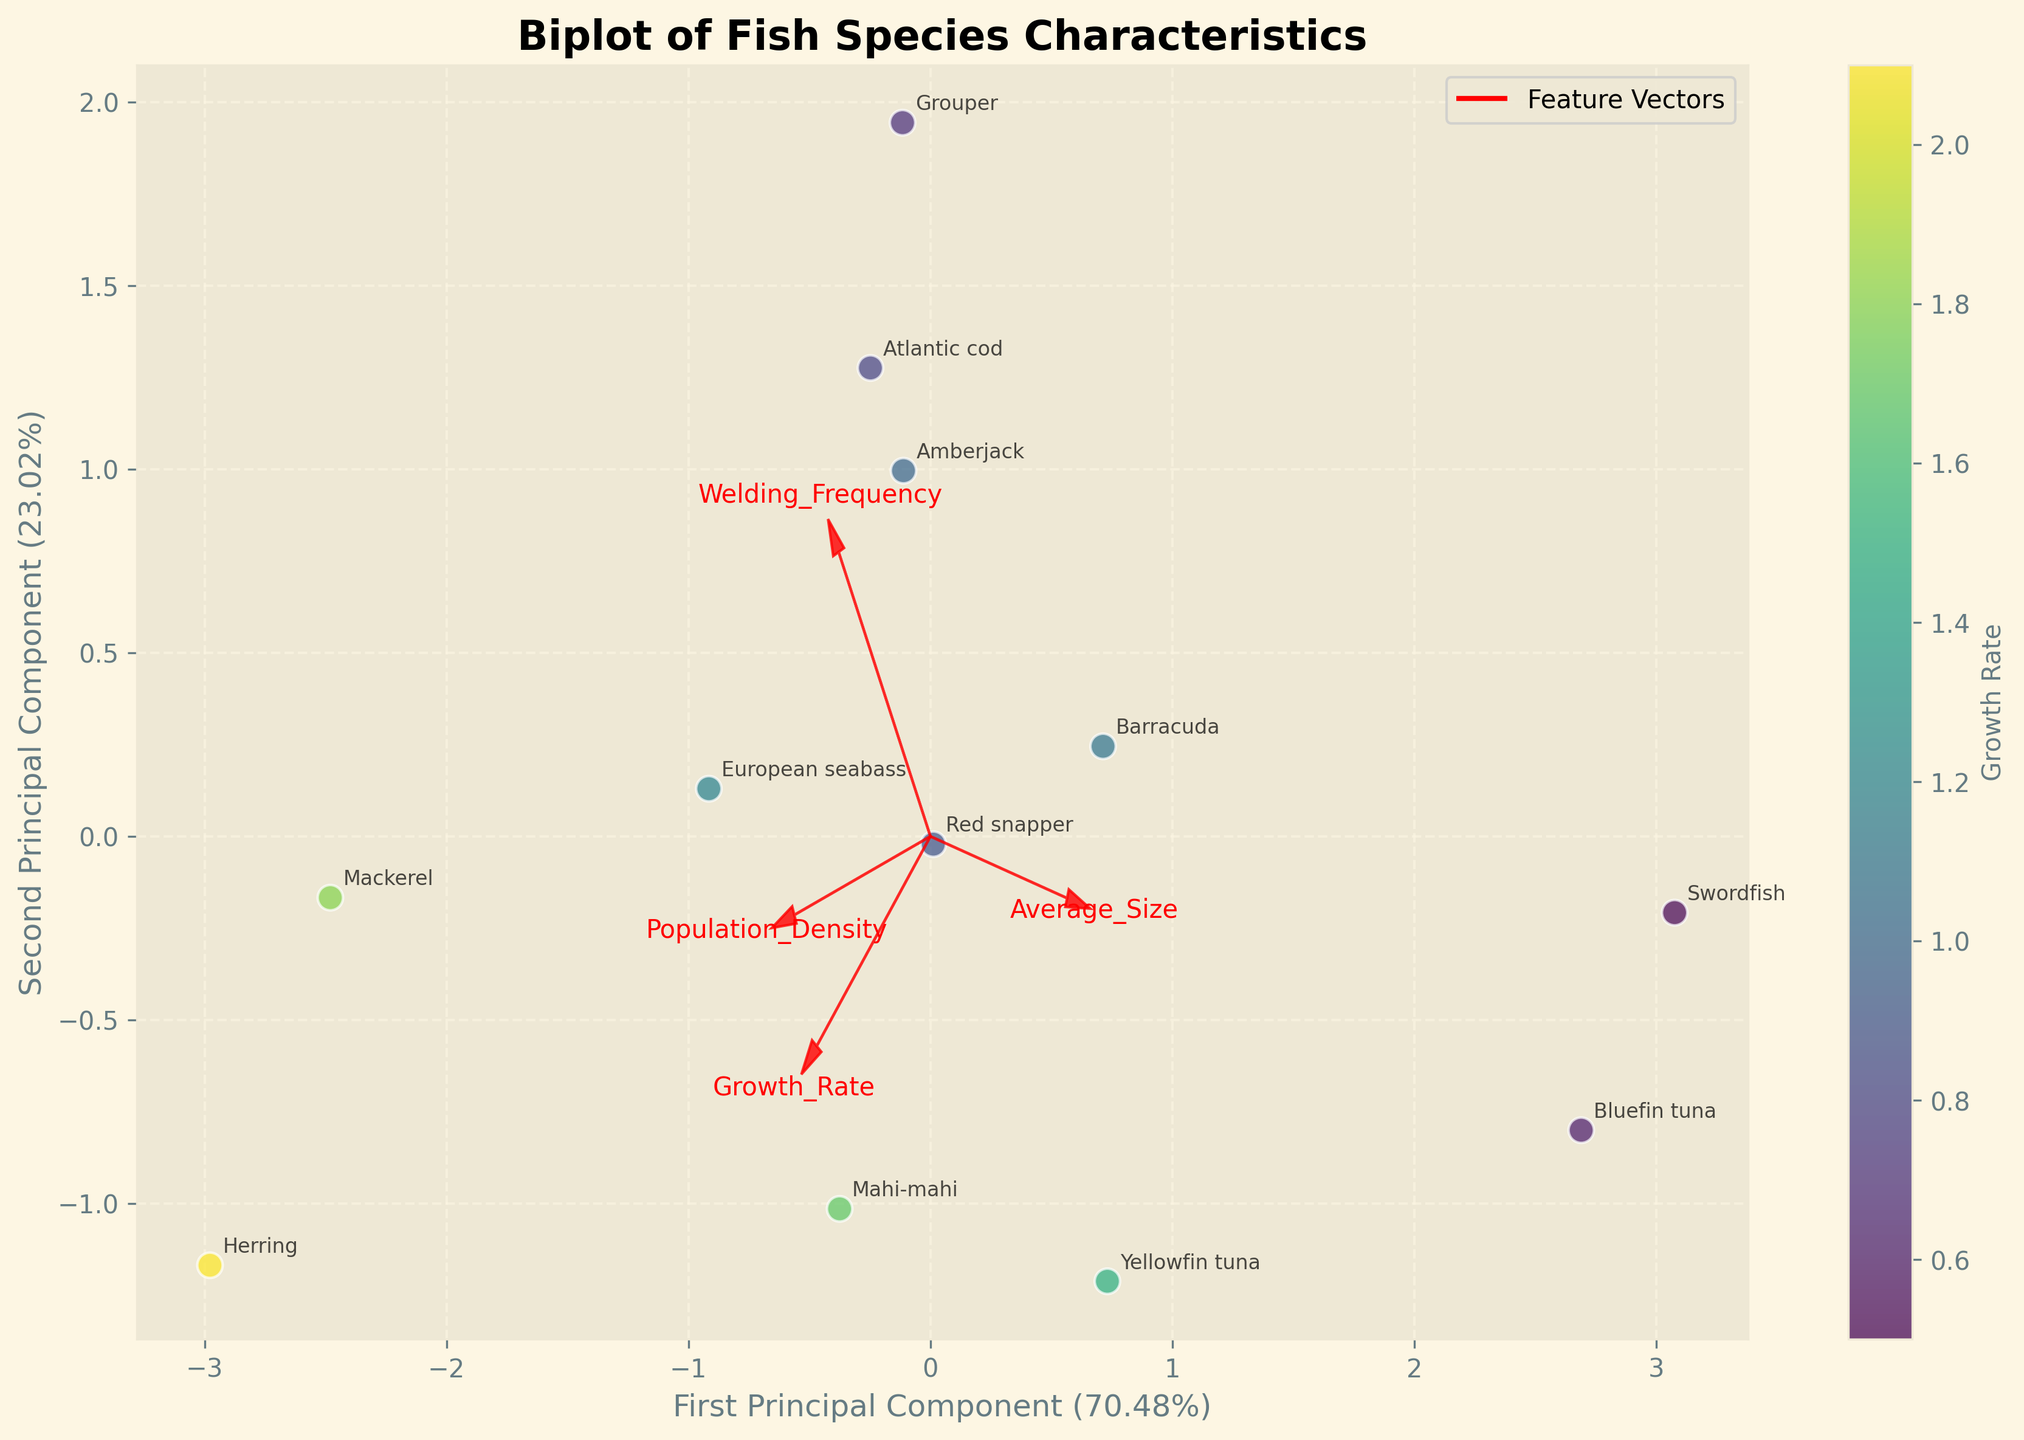Which fish species is located closest to the origin in the biplot? The origin in the biplot represents the point (0, 0) in the principal component space. By observing the biplot, the fish species located closest to this point is identified.
Answer: European seabass Which fish species shows the highest growth rate according to the color gradient? The color gradient in the biplot represents the growth rate, with the highest rate indicated by the brightest color in the 'viridis' colormap. By examining the color of the points, the fish species with the highest growth rate can be identified.
Answer: Herring What is the angle between the 'Growth Rate' and 'Welding Frequency' vectors? The angle between two vectors in a biplot indicates the correlation between those variables. An acute angle (< 90 degrees) implies a positive correlation, an obtuse angle (> 90 degrees) implies a negative correlation, and a right angle (90 degrees) implies no correlation. By examining the plot, both vectors make a roughly acute angle.
Answer: Positive correlation Which fish species has the lowest population density? Population density is represented in the axes of the biplot, and by examining the scatter plot locations within the vectors, the species that lies further from the 'Population Density' vector (or closer to the lower end of this vector's direction) can be identified.
Answer: Swordfish Which two species are most similar in terms of PCA components? By observing the positions of the data points in the biplot and identifying the two species that are closest to each other in the principal component space, their similarity in terms of PCA components can be inferred.
Answer: Red snapper and Mahi-mahi What can we infer if a species point lies far from the 'Average Size' vector in the biplot? In a biplot, the distance of a species point from a feature vector suggests how strongly (or weakly) that feature influences the species. A point far from the 'Average Size' vector indicates that the 'Average Size' is not a significant factor for that species.
Answer: Weak influence of Average Size Which species appears to have a strong relationship between Average Size and Welding Frequency? In a biplot, vectors that are close to each other or almost linearly aligned to data points indicate a strong relationship between the variables they represent. By observing the alignment and positions with respect to 'Average Size' and 'Welding Frequency' vectors, the corresponding species can be identified.
Answer: Bluefin tuna What feature most heavily influences the first principal component? The first principal component's influence is measured by the projection of feature vectors along its axis. The longer (or further) the projection, the more influential the feature is. By observing the biplot, Average Size vector has the highest projection on the first principal component.
Answer: Average Size How does Mackerel compare in terms of growth rate and population density to Yellowfin tuna? By examining the positions of the Mackerel and Yellowfin tuna on the biplot, the growth rate (represented by color) and their locations relative to the 'Population Density' vector can be compared. Mackerel has a higher growth rate and positioned further along the 'Population Density' axis.
Answer: Higher growth rate; Higher population density for Mackerel Which species has the largest average size? By observing the biplot and identifying the data point that lies furthest in the positive direction along the 'Average Size' vector, the species with the largest average size can be determined.
Answer: Swordfish 